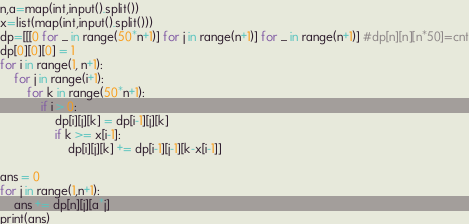Convert code to text. <code><loc_0><loc_0><loc_500><loc_500><_Python_>n,a=map(int,input().split())
x=list(map(int,input().split()))
dp=[[[0 for _ in range(50*n+1)] for j in range(n+1)] for _ in range(n+1)] #dp[n][n][n*50]=cnt
dp[0][0][0] = 1
for i in range(1, n+1):
    for j in range(i+1):
        for k in range(50*n+1):
            if i > 0:
                dp[i][j][k] = dp[i-1][j][k]
                if k >= x[i-1]:
                    dp[i][j][k] += dp[i-1][j-1][k-x[i-1]]

ans = 0
for j in range(1,n+1):
    ans += dp[n][j][a*j]
print(ans)
</code> 